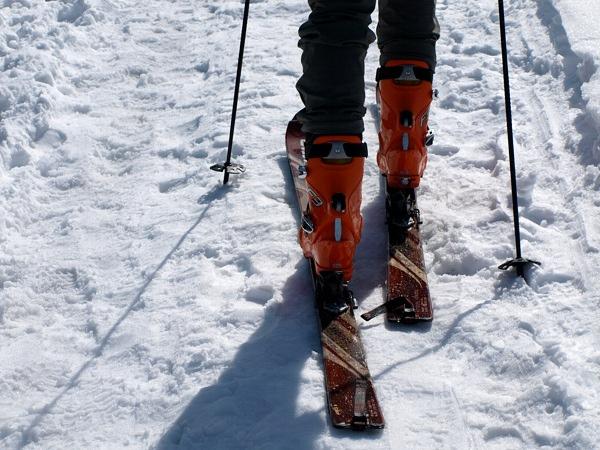Where are the tips of the ski's?
Quick response, please. Front. What is the person in the photo doing?
Keep it brief. Skiing. Are the skis made out of plastic?
Keep it brief. No. 